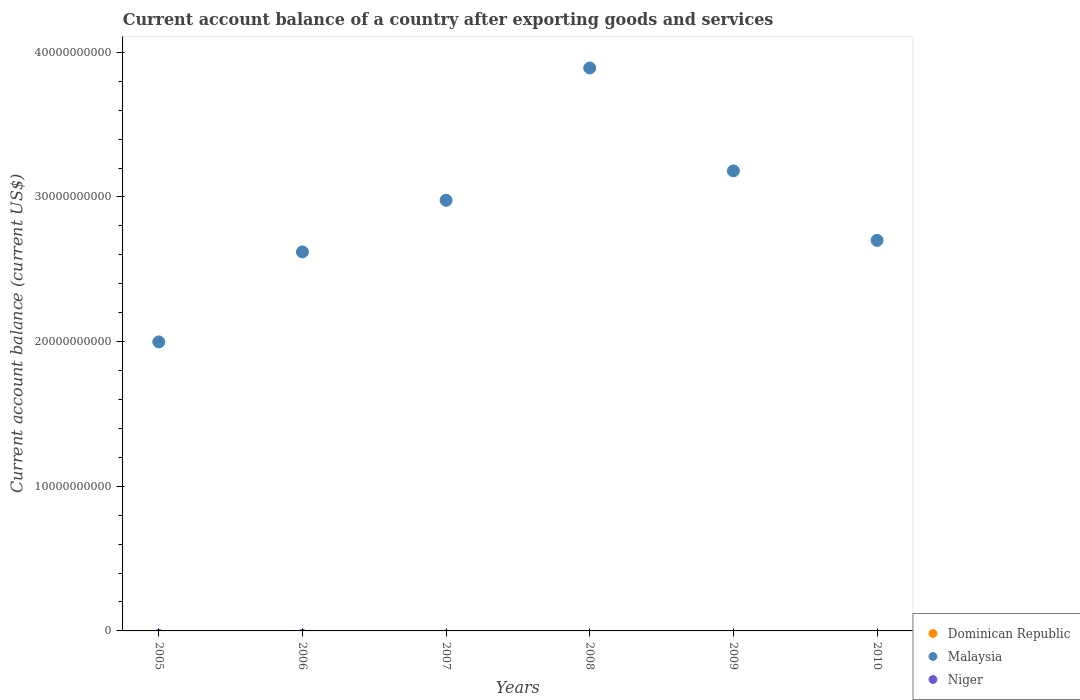How many different coloured dotlines are there?
Offer a terse response. 1. Is the number of dotlines equal to the number of legend labels?
Your answer should be compact. No. What is the account balance in Dominican Republic in 2007?
Your response must be concise. 0. Across all years, what is the maximum account balance in Malaysia?
Your answer should be very brief. 3.89e+1. Across all years, what is the minimum account balance in Malaysia?
Your response must be concise. 2.00e+1. What is the total account balance in Dominican Republic in the graph?
Provide a short and direct response. 0. What is the difference between the account balance in Malaysia in 2005 and that in 2006?
Your response must be concise. -6.22e+09. What is the difference between the account balance in Malaysia in 2009 and the account balance in Niger in 2007?
Make the answer very short. 3.18e+1. In how many years, is the account balance in Dominican Republic greater than 30000000000 US$?
Offer a terse response. 0. What is the ratio of the account balance in Malaysia in 2006 to that in 2007?
Offer a terse response. 0.88. What is the difference between the highest and the second highest account balance in Malaysia?
Ensure brevity in your answer.  7.11e+09. What is the difference between the highest and the lowest account balance in Malaysia?
Your response must be concise. 1.89e+1. In how many years, is the account balance in Dominican Republic greater than the average account balance in Dominican Republic taken over all years?
Your response must be concise. 0. Is the sum of the account balance in Malaysia in 2007 and 2008 greater than the maximum account balance in Niger across all years?
Ensure brevity in your answer.  Yes. Is it the case that in every year, the sum of the account balance in Dominican Republic and account balance in Malaysia  is greater than the account balance in Niger?
Ensure brevity in your answer.  Yes. Does the account balance in Niger monotonically increase over the years?
Your answer should be compact. No. How many dotlines are there?
Keep it short and to the point. 1. What is the difference between two consecutive major ticks on the Y-axis?
Make the answer very short. 1.00e+1. Are the values on the major ticks of Y-axis written in scientific E-notation?
Your response must be concise. No. Does the graph contain any zero values?
Ensure brevity in your answer.  Yes. Does the graph contain grids?
Your response must be concise. No. Where does the legend appear in the graph?
Your answer should be very brief. Bottom right. How many legend labels are there?
Keep it short and to the point. 3. How are the legend labels stacked?
Offer a terse response. Vertical. What is the title of the graph?
Provide a succinct answer. Current account balance of a country after exporting goods and services. Does "Mauritania" appear as one of the legend labels in the graph?
Your answer should be very brief. No. What is the label or title of the X-axis?
Offer a very short reply. Years. What is the label or title of the Y-axis?
Ensure brevity in your answer.  Current account balance (current US$). What is the Current account balance (current US$) of Dominican Republic in 2005?
Give a very brief answer. 0. What is the Current account balance (current US$) in Malaysia in 2005?
Your answer should be very brief. 2.00e+1. What is the Current account balance (current US$) in Malaysia in 2006?
Ensure brevity in your answer.  2.62e+1. What is the Current account balance (current US$) of Malaysia in 2007?
Your answer should be compact. 2.98e+1. What is the Current account balance (current US$) of Dominican Republic in 2008?
Your answer should be compact. 0. What is the Current account balance (current US$) of Malaysia in 2008?
Your answer should be compact. 3.89e+1. What is the Current account balance (current US$) of Malaysia in 2009?
Your answer should be very brief. 3.18e+1. What is the Current account balance (current US$) of Niger in 2009?
Your answer should be compact. 0. What is the Current account balance (current US$) of Dominican Republic in 2010?
Ensure brevity in your answer.  0. What is the Current account balance (current US$) of Malaysia in 2010?
Your response must be concise. 2.70e+1. What is the Current account balance (current US$) of Niger in 2010?
Provide a short and direct response. 0. Across all years, what is the maximum Current account balance (current US$) of Malaysia?
Make the answer very short. 3.89e+1. Across all years, what is the minimum Current account balance (current US$) in Malaysia?
Provide a short and direct response. 2.00e+1. What is the total Current account balance (current US$) in Dominican Republic in the graph?
Provide a succinct answer. 0. What is the total Current account balance (current US$) of Malaysia in the graph?
Your response must be concise. 1.74e+11. What is the difference between the Current account balance (current US$) in Malaysia in 2005 and that in 2006?
Your answer should be very brief. -6.22e+09. What is the difference between the Current account balance (current US$) of Malaysia in 2005 and that in 2007?
Your response must be concise. -9.79e+09. What is the difference between the Current account balance (current US$) in Malaysia in 2005 and that in 2008?
Provide a succinct answer. -1.89e+1. What is the difference between the Current account balance (current US$) of Malaysia in 2005 and that in 2009?
Make the answer very short. -1.18e+1. What is the difference between the Current account balance (current US$) of Malaysia in 2005 and that in 2010?
Your answer should be compact. -7.02e+09. What is the difference between the Current account balance (current US$) of Malaysia in 2006 and that in 2007?
Offer a very short reply. -3.57e+09. What is the difference between the Current account balance (current US$) of Malaysia in 2006 and that in 2008?
Give a very brief answer. -1.27e+1. What is the difference between the Current account balance (current US$) in Malaysia in 2006 and that in 2009?
Ensure brevity in your answer.  -5.60e+09. What is the difference between the Current account balance (current US$) in Malaysia in 2006 and that in 2010?
Make the answer very short. -7.99e+08. What is the difference between the Current account balance (current US$) in Malaysia in 2007 and that in 2008?
Ensure brevity in your answer.  -9.14e+09. What is the difference between the Current account balance (current US$) of Malaysia in 2007 and that in 2009?
Offer a very short reply. -2.03e+09. What is the difference between the Current account balance (current US$) in Malaysia in 2007 and that in 2010?
Your response must be concise. 2.77e+09. What is the difference between the Current account balance (current US$) in Malaysia in 2008 and that in 2009?
Provide a short and direct response. 7.11e+09. What is the difference between the Current account balance (current US$) in Malaysia in 2008 and that in 2010?
Offer a very short reply. 1.19e+1. What is the difference between the Current account balance (current US$) of Malaysia in 2009 and that in 2010?
Your answer should be very brief. 4.80e+09. What is the average Current account balance (current US$) in Malaysia per year?
Ensure brevity in your answer.  2.89e+1. What is the ratio of the Current account balance (current US$) in Malaysia in 2005 to that in 2006?
Offer a terse response. 0.76. What is the ratio of the Current account balance (current US$) in Malaysia in 2005 to that in 2007?
Your answer should be compact. 0.67. What is the ratio of the Current account balance (current US$) of Malaysia in 2005 to that in 2008?
Ensure brevity in your answer.  0.51. What is the ratio of the Current account balance (current US$) of Malaysia in 2005 to that in 2009?
Offer a terse response. 0.63. What is the ratio of the Current account balance (current US$) of Malaysia in 2005 to that in 2010?
Make the answer very short. 0.74. What is the ratio of the Current account balance (current US$) of Malaysia in 2006 to that in 2007?
Your answer should be very brief. 0.88. What is the ratio of the Current account balance (current US$) in Malaysia in 2006 to that in 2008?
Offer a terse response. 0.67. What is the ratio of the Current account balance (current US$) in Malaysia in 2006 to that in 2009?
Offer a terse response. 0.82. What is the ratio of the Current account balance (current US$) of Malaysia in 2006 to that in 2010?
Offer a very short reply. 0.97. What is the ratio of the Current account balance (current US$) in Malaysia in 2007 to that in 2008?
Your answer should be very brief. 0.77. What is the ratio of the Current account balance (current US$) of Malaysia in 2007 to that in 2009?
Ensure brevity in your answer.  0.94. What is the ratio of the Current account balance (current US$) in Malaysia in 2007 to that in 2010?
Offer a very short reply. 1.1. What is the ratio of the Current account balance (current US$) of Malaysia in 2008 to that in 2009?
Offer a terse response. 1.22. What is the ratio of the Current account balance (current US$) in Malaysia in 2008 to that in 2010?
Ensure brevity in your answer.  1.44. What is the ratio of the Current account balance (current US$) of Malaysia in 2009 to that in 2010?
Your response must be concise. 1.18. What is the difference between the highest and the second highest Current account balance (current US$) in Malaysia?
Give a very brief answer. 7.11e+09. What is the difference between the highest and the lowest Current account balance (current US$) in Malaysia?
Provide a short and direct response. 1.89e+1. 